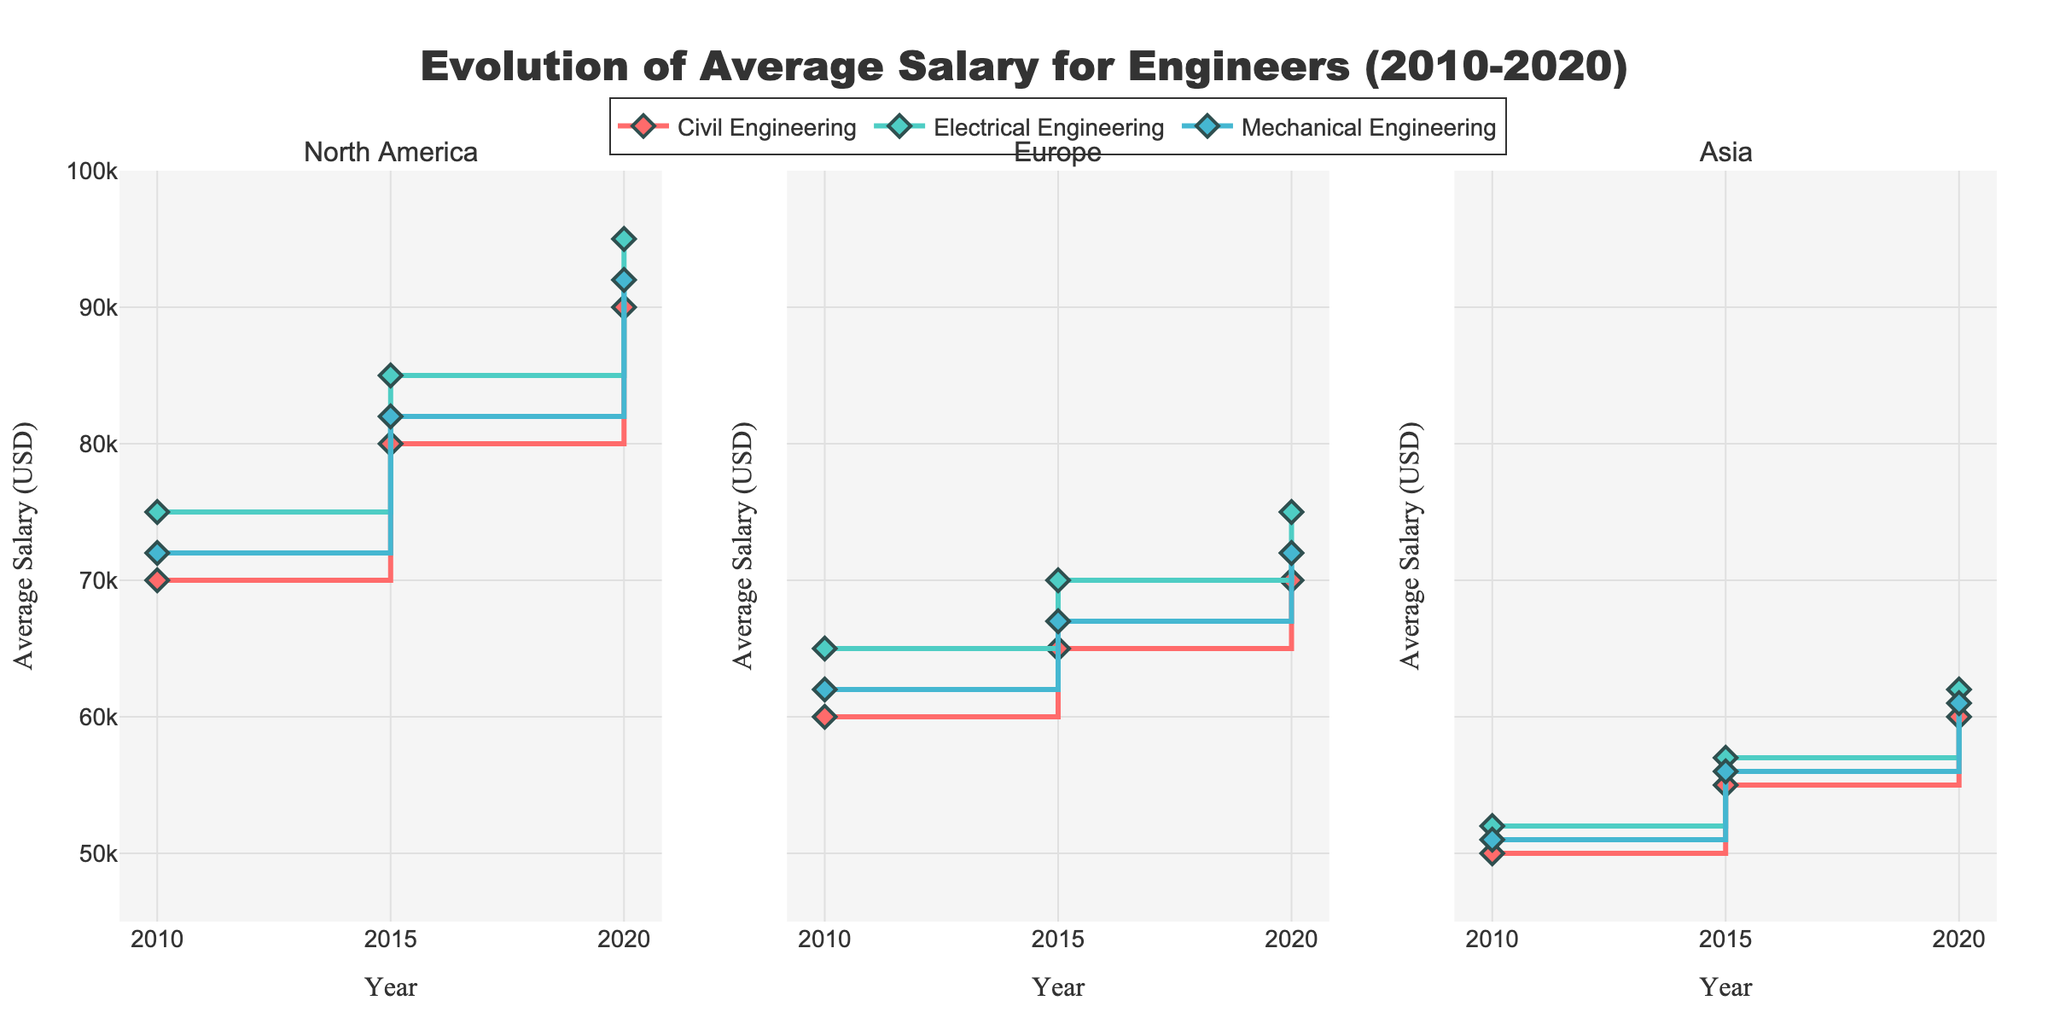what is the title of the figure? The title of the figure is located at the top and centered. It is typically large and in bold to stand out.
Answer: Evolution of Average Salary for Engineers (2010-2020) How many regions are compared in the figure? The figure has three subplot titles at the top, each representing a different region.
Answer: 3 What color represents Mechanical Engineering? Each discipline has a distinct color with a legend at the bottom that indicates which color corresponds to which discipline.
Answer: #45B7D1 Which discipline in North America had the smallest salary increase from 2010 to 2020? In the North America subplot, observe the vertical distance of lines for each discipline from 2010 to 2020. The smallest increase would have the shortest vertical line from 2010 to 2020.
Answer: Civil Engineering What is the average salary of Electrical Engineering in Europe in 2020? Look at the Europe subplot, follow the Electrical Engineering line to the year 2020, and read the corresponding y-axis value.
Answer: 75000 Which region had the highest average salary for Civil Engineers in 2020? For each region, look at the Civil Engineering line in the year 2020 and compare the y-axis values. Ensure to check North America, Europe, and Asia regions.
Answer: North America What is the overall percentage increase in the average salary for Mechanical Engineering in Asia from 2010 to 2020? Identify the starting value in 2010 and ending value in 2020 for Mechanical Engineering in Asia. Use the formula [(2020 value - 2010 value) / 2010 value] * 100 to calculate the percentage increase.
Answer: 20% Which discipline had the most consistent salary growth in North America? In the North America subplot, analyze the slopes of the lines for Civil, Electrical, and Mechanical Engineering. The most consistent will have the smallest variation in slope across the years.
Answer: Electrical Engineering Between 2015 and 2020, which region had the highest increase in the average salary for Civil Engineers? Compare the change in Civil Engineering salaries between 2015 and 2020 for North America, Europe, and Asia by observing the vertical distance on the y-axis.
Answer: North America 